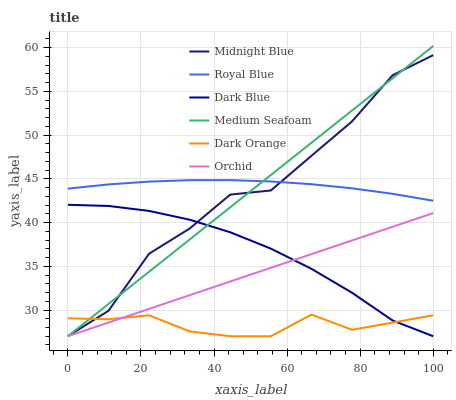Does Dark Orange have the minimum area under the curve?
Answer yes or no. Yes. Does Royal Blue have the maximum area under the curve?
Answer yes or no. Yes. Does Midnight Blue have the minimum area under the curve?
Answer yes or no. No. Does Midnight Blue have the maximum area under the curve?
Answer yes or no. No. Is Medium Seafoam the smoothest?
Answer yes or no. Yes. Is Midnight Blue the roughest?
Answer yes or no. Yes. Is Dark Blue the smoothest?
Answer yes or no. No. Is Dark Blue the roughest?
Answer yes or no. No. Does Royal Blue have the lowest value?
Answer yes or no. No. Does Medium Seafoam have the highest value?
Answer yes or no. Yes. Does Midnight Blue have the highest value?
Answer yes or no. No. Is Dark Blue less than Royal Blue?
Answer yes or no. Yes. Is Royal Blue greater than Dark Blue?
Answer yes or no. Yes. Does Orchid intersect Dark Blue?
Answer yes or no. Yes. Is Orchid less than Dark Blue?
Answer yes or no. No. Is Orchid greater than Dark Blue?
Answer yes or no. No. Does Dark Blue intersect Royal Blue?
Answer yes or no. No. 